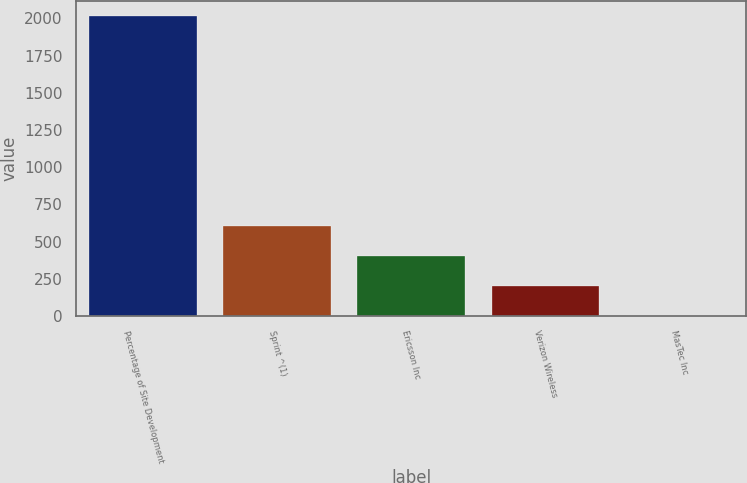Convert chart. <chart><loc_0><loc_0><loc_500><loc_500><bar_chart><fcel>Percentage of Site Development<fcel>Sprint ^(1)<fcel>Ericsson Inc<fcel>Verizon Wireless<fcel>MasTec Inc<nl><fcel>2014<fcel>605.53<fcel>404.32<fcel>203.11<fcel>1.9<nl></chart> 